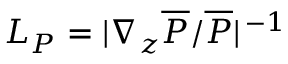Convert formula to latex. <formula><loc_0><loc_0><loc_500><loc_500>L _ { P } = | \nabla _ { z } \overline { P } / \overline { P } | ^ { \, - 1 }</formula> 